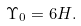<formula> <loc_0><loc_0><loc_500><loc_500>\Upsilon _ { 0 } = 6 H .</formula> 